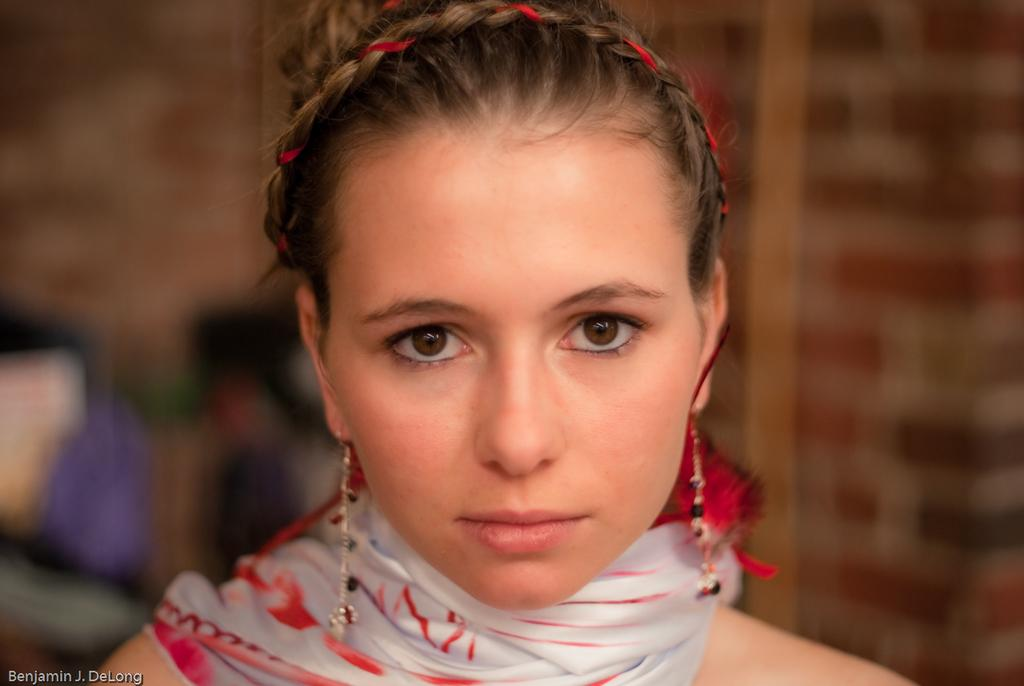Who is present in the image? There is a woman in the image. What is the woman doing in the image? The woman is watching something. Can you describe the background of the image? The background of the image is blurred. Is there any additional information or markings on the image? Yes, there is a watermark in the left side bottom corner of the image. What type of lock is visible on the woman's suit in the image? There is no suit or lock present in the image; it features a woman watching something with a blurred background and a watermark. 